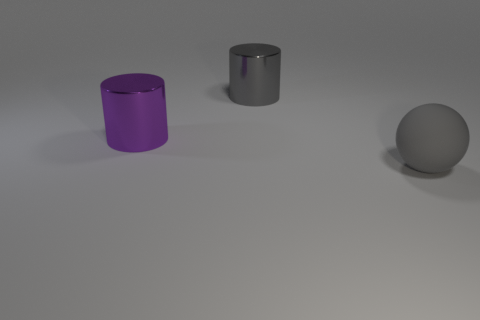Are there any indications about the location where this photo was taken? The photo lacks contextual details that would indicate a specific location. The plain background and the absence of external references point to this being a staged scene, possibly within a studio setup designed to highlight the objects without distraction. 